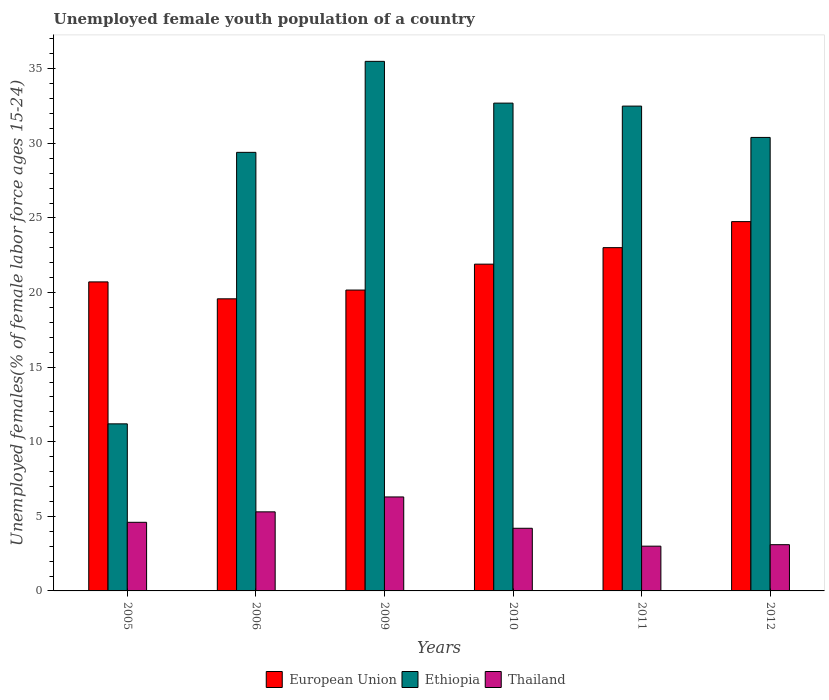How many different coloured bars are there?
Your response must be concise. 3. Are the number of bars per tick equal to the number of legend labels?
Your response must be concise. Yes. How many bars are there on the 6th tick from the left?
Provide a short and direct response. 3. How many bars are there on the 6th tick from the right?
Provide a short and direct response. 3. What is the label of the 2nd group of bars from the left?
Keep it short and to the point. 2006. In how many cases, is the number of bars for a given year not equal to the number of legend labels?
Your answer should be very brief. 0. What is the percentage of unemployed female youth population in European Union in 2009?
Offer a terse response. 20.17. Across all years, what is the maximum percentage of unemployed female youth population in Thailand?
Offer a very short reply. 6.3. Across all years, what is the minimum percentage of unemployed female youth population in Thailand?
Offer a very short reply. 3. What is the total percentage of unemployed female youth population in Ethiopia in the graph?
Your answer should be compact. 171.7. What is the difference between the percentage of unemployed female youth population in European Union in 2011 and that in 2012?
Keep it short and to the point. -1.75. What is the difference between the percentage of unemployed female youth population in Ethiopia in 2010 and the percentage of unemployed female youth population in European Union in 2012?
Give a very brief answer. 7.94. What is the average percentage of unemployed female youth population in Ethiopia per year?
Make the answer very short. 28.62. In the year 2006, what is the difference between the percentage of unemployed female youth population in European Union and percentage of unemployed female youth population in Thailand?
Your answer should be compact. 14.28. What is the ratio of the percentage of unemployed female youth population in Thailand in 2009 to that in 2011?
Your answer should be compact. 2.1. Is the difference between the percentage of unemployed female youth population in European Union in 2005 and 2009 greater than the difference between the percentage of unemployed female youth population in Thailand in 2005 and 2009?
Offer a terse response. Yes. What is the difference between the highest and the second highest percentage of unemployed female youth population in Thailand?
Provide a short and direct response. 1. What is the difference between the highest and the lowest percentage of unemployed female youth population in Thailand?
Give a very brief answer. 3.3. In how many years, is the percentage of unemployed female youth population in Thailand greater than the average percentage of unemployed female youth population in Thailand taken over all years?
Offer a terse response. 3. What does the 2nd bar from the left in 2010 represents?
Provide a short and direct response. Ethiopia. What does the 2nd bar from the right in 2006 represents?
Keep it short and to the point. Ethiopia. Is it the case that in every year, the sum of the percentage of unemployed female youth population in Thailand and percentage of unemployed female youth population in Ethiopia is greater than the percentage of unemployed female youth population in European Union?
Keep it short and to the point. No. How many years are there in the graph?
Your response must be concise. 6. What is the difference between two consecutive major ticks on the Y-axis?
Make the answer very short. 5. Does the graph contain any zero values?
Provide a short and direct response. No. Does the graph contain grids?
Provide a succinct answer. No. How many legend labels are there?
Make the answer very short. 3. How are the legend labels stacked?
Keep it short and to the point. Horizontal. What is the title of the graph?
Provide a succinct answer. Unemployed female youth population of a country. Does "Guatemala" appear as one of the legend labels in the graph?
Offer a very short reply. No. What is the label or title of the X-axis?
Offer a very short reply. Years. What is the label or title of the Y-axis?
Your answer should be very brief. Unemployed females(% of female labor force ages 15-24). What is the Unemployed females(% of female labor force ages 15-24) of European Union in 2005?
Make the answer very short. 20.72. What is the Unemployed females(% of female labor force ages 15-24) in Ethiopia in 2005?
Give a very brief answer. 11.2. What is the Unemployed females(% of female labor force ages 15-24) of Thailand in 2005?
Your answer should be compact. 4.6. What is the Unemployed females(% of female labor force ages 15-24) of European Union in 2006?
Your answer should be very brief. 19.58. What is the Unemployed females(% of female labor force ages 15-24) of Ethiopia in 2006?
Give a very brief answer. 29.4. What is the Unemployed females(% of female labor force ages 15-24) of Thailand in 2006?
Ensure brevity in your answer.  5.3. What is the Unemployed females(% of female labor force ages 15-24) of European Union in 2009?
Your response must be concise. 20.17. What is the Unemployed females(% of female labor force ages 15-24) of Ethiopia in 2009?
Your answer should be compact. 35.5. What is the Unemployed females(% of female labor force ages 15-24) of Thailand in 2009?
Give a very brief answer. 6.3. What is the Unemployed females(% of female labor force ages 15-24) in European Union in 2010?
Ensure brevity in your answer.  21.91. What is the Unemployed females(% of female labor force ages 15-24) of Ethiopia in 2010?
Offer a terse response. 32.7. What is the Unemployed females(% of female labor force ages 15-24) of Thailand in 2010?
Your answer should be compact. 4.2. What is the Unemployed females(% of female labor force ages 15-24) in European Union in 2011?
Your answer should be compact. 23.01. What is the Unemployed females(% of female labor force ages 15-24) of Ethiopia in 2011?
Your answer should be very brief. 32.5. What is the Unemployed females(% of female labor force ages 15-24) of European Union in 2012?
Make the answer very short. 24.76. What is the Unemployed females(% of female labor force ages 15-24) in Ethiopia in 2012?
Offer a very short reply. 30.4. What is the Unemployed females(% of female labor force ages 15-24) in Thailand in 2012?
Offer a very short reply. 3.1. Across all years, what is the maximum Unemployed females(% of female labor force ages 15-24) in European Union?
Make the answer very short. 24.76. Across all years, what is the maximum Unemployed females(% of female labor force ages 15-24) of Ethiopia?
Provide a succinct answer. 35.5. Across all years, what is the maximum Unemployed females(% of female labor force ages 15-24) in Thailand?
Give a very brief answer. 6.3. Across all years, what is the minimum Unemployed females(% of female labor force ages 15-24) of European Union?
Ensure brevity in your answer.  19.58. Across all years, what is the minimum Unemployed females(% of female labor force ages 15-24) in Ethiopia?
Offer a very short reply. 11.2. What is the total Unemployed females(% of female labor force ages 15-24) of European Union in the graph?
Keep it short and to the point. 130.14. What is the total Unemployed females(% of female labor force ages 15-24) of Ethiopia in the graph?
Give a very brief answer. 171.7. What is the difference between the Unemployed females(% of female labor force ages 15-24) in European Union in 2005 and that in 2006?
Offer a terse response. 1.13. What is the difference between the Unemployed females(% of female labor force ages 15-24) in Ethiopia in 2005 and that in 2006?
Offer a very short reply. -18.2. What is the difference between the Unemployed females(% of female labor force ages 15-24) of European Union in 2005 and that in 2009?
Offer a very short reply. 0.55. What is the difference between the Unemployed females(% of female labor force ages 15-24) of Ethiopia in 2005 and that in 2009?
Keep it short and to the point. -24.3. What is the difference between the Unemployed females(% of female labor force ages 15-24) of Thailand in 2005 and that in 2009?
Give a very brief answer. -1.7. What is the difference between the Unemployed females(% of female labor force ages 15-24) in European Union in 2005 and that in 2010?
Provide a succinct answer. -1.19. What is the difference between the Unemployed females(% of female labor force ages 15-24) of Ethiopia in 2005 and that in 2010?
Your answer should be very brief. -21.5. What is the difference between the Unemployed females(% of female labor force ages 15-24) of Thailand in 2005 and that in 2010?
Your answer should be compact. 0.4. What is the difference between the Unemployed females(% of female labor force ages 15-24) of European Union in 2005 and that in 2011?
Your answer should be compact. -2.3. What is the difference between the Unemployed females(% of female labor force ages 15-24) in Ethiopia in 2005 and that in 2011?
Your answer should be compact. -21.3. What is the difference between the Unemployed females(% of female labor force ages 15-24) in European Union in 2005 and that in 2012?
Offer a terse response. -4.04. What is the difference between the Unemployed females(% of female labor force ages 15-24) in Ethiopia in 2005 and that in 2012?
Give a very brief answer. -19.2. What is the difference between the Unemployed females(% of female labor force ages 15-24) in Thailand in 2005 and that in 2012?
Your answer should be compact. 1.5. What is the difference between the Unemployed females(% of female labor force ages 15-24) of European Union in 2006 and that in 2009?
Your response must be concise. -0.59. What is the difference between the Unemployed females(% of female labor force ages 15-24) in Thailand in 2006 and that in 2009?
Your answer should be very brief. -1. What is the difference between the Unemployed females(% of female labor force ages 15-24) of European Union in 2006 and that in 2010?
Your response must be concise. -2.32. What is the difference between the Unemployed females(% of female labor force ages 15-24) of Thailand in 2006 and that in 2010?
Your answer should be compact. 1.1. What is the difference between the Unemployed females(% of female labor force ages 15-24) of European Union in 2006 and that in 2011?
Ensure brevity in your answer.  -3.43. What is the difference between the Unemployed females(% of female labor force ages 15-24) of European Union in 2006 and that in 2012?
Ensure brevity in your answer.  -5.18. What is the difference between the Unemployed females(% of female labor force ages 15-24) in European Union in 2009 and that in 2010?
Ensure brevity in your answer.  -1.74. What is the difference between the Unemployed females(% of female labor force ages 15-24) of Ethiopia in 2009 and that in 2010?
Give a very brief answer. 2.8. What is the difference between the Unemployed females(% of female labor force ages 15-24) in European Union in 2009 and that in 2011?
Make the answer very short. -2.84. What is the difference between the Unemployed females(% of female labor force ages 15-24) in Ethiopia in 2009 and that in 2011?
Give a very brief answer. 3. What is the difference between the Unemployed females(% of female labor force ages 15-24) in Thailand in 2009 and that in 2011?
Your response must be concise. 3.3. What is the difference between the Unemployed females(% of female labor force ages 15-24) in European Union in 2009 and that in 2012?
Give a very brief answer. -4.59. What is the difference between the Unemployed females(% of female labor force ages 15-24) in Ethiopia in 2009 and that in 2012?
Provide a short and direct response. 5.1. What is the difference between the Unemployed females(% of female labor force ages 15-24) of Thailand in 2009 and that in 2012?
Make the answer very short. 3.2. What is the difference between the Unemployed females(% of female labor force ages 15-24) of European Union in 2010 and that in 2011?
Ensure brevity in your answer.  -1.11. What is the difference between the Unemployed females(% of female labor force ages 15-24) in Thailand in 2010 and that in 2011?
Your answer should be very brief. 1.2. What is the difference between the Unemployed females(% of female labor force ages 15-24) of European Union in 2010 and that in 2012?
Make the answer very short. -2.85. What is the difference between the Unemployed females(% of female labor force ages 15-24) in European Union in 2011 and that in 2012?
Your response must be concise. -1.75. What is the difference between the Unemployed females(% of female labor force ages 15-24) in European Union in 2005 and the Unemployed females(% of female labor force ages 15-24) in Ethiopia in 2006?
Provide a short and direct response. -8.68. What is the difference between the Unemployed females(% of female labor force ages 15-24) in European Union in 2005 and the Unemployed females(% of female labor force ages 15-24) in Thailand in 2006?
Ensure brevity in your answer.  15.42. What is the difference between the Unemployed females(% of female labor force ages 15-24) of European Union in 2005 and the Unemployed females(% of female labor force ages 15-24) of Ethiopia in 2009?
Your answer should be very brief. -14.78. What is the difference between the Unemployed females(% of female labor force ages 15-24) in European Union in 2005 and the Unemployed females(% of female labor force ages 15-24) in Thailand in 2009?
Provide a succinct answer. 14.42. What is the difference between the Unemployed females(% of female labor force ages 15-24) of European Union in 2005 and the Unemployed females(% of female labor force ages 15-24) of Ethiopia in 2010?
Make the answer very short. -11.98. What is the difference between the Unemployed females(% of female labor force ages 15-24) of European Union in 2005 and the Unemployed females(% of female labor force ages 15-24) of Thailand in 2010?
Your answer should be very brief. 16.52. What is the difference between the Unemployed females(% of female labor force ages 15-24) in Ethiopia in 2005 and the Unemployed females(% of female labor force ages 15-24) in Thailand in 2010?
Offer a terse response. 7. What is the difference between the Unemployed females(% of female labor force ages 15-24) in European Union in 2005 and the Unemployed females(% of female labor force ages 15-24) in Ethiopia in 2011?
Make the answer very short. -11.78. What is the difference between the Unemployed females(% of female labor force ages 15-24) in European Union in 2005 and the Unemployed females(% of female labor force ages 15-24) in Thailand in 2011?
Offer a terse response. 17.72. What is the difference between the Unemployed females(% of female labor force ages 15-24) in Ethiopia in 2005 and the Unemployed females(% of female labor force ages 15-24) in Thailand in 2011?
Ensure brevity in your answer.  8.2. What is the difference between the Unemployed females(% of female labor force ages 15-24) of European Union in 2005 and the Unemployed females(% of female labor force ages 15-24) of Ethiopia in 2012?
Your response must be concise. -9.68. What is the difference between the Unemployed females(% of female labor force ages 15-24) in European Union in 2005 and the Unemployed females(% of female labor force ages 15-24) in Thailand in 2012?
Provide a succinct answer. 17.62. What is the difference between the Unemployed females(% of female labor force ages 15-24) of European Union in 2006 and the Unemployed females(% of female labor force ages 15-24) of Ethiopia in 2009?
Your answer should be very brief. -15.92. What is the difference between the Unemployed females(% of female labor force ages 15-24) in European Union in 2006 and the Unemployed females(% of female labor force ages 15-24) in Thailand in 2009?
Provide a succinct answer. 13.28. What is the difference between the Unemployed females(% of female labor force ages 15-24) in Ethiopia in 2006 and the Unemployed females(% of female labor force ages 15-24) in Thailand in 2009?
Provide a succinct answer. 23.1. What is the difference between the Unemployed females(% of female labor force ages 15-24) in European Union in 2006 and the Unemployed females(% of female labor force ages 15-24) in Ethiopia in 2010?
Your response must be concise. -13.12. What is the difference between the Unemployed females(% of female labor force ages 15-24) of European Union in 2006 and the Unemployed females(% of female labor force ages 15-24) of Thailand in 2010?
Give a very brief answer. 15.38. What is the difference between the Unemployed females(% of female labor force ages 15-24) of Ethiopia in 2006 and the Unemployed females(% of female labor force ages 15-24) of Thailand in 2010?
Your answer should be compact. 25.2. What is the difference between the Unemployed females(% of female labor force ages 15-24) of European Union in 2006 and the Unemployed females(% of female labor force ages 15-24) of Ethiopia in 2011?
Keep it short and to the point. -12.92. What is the difference between the Unemployed females(% of female labor force ages 15-24) of European Union in 2006 and the Unemployed females(% of female labor force ages 15-24) of Thailand in 2011?
Make the answer very short. 16.58. What is the difference between the Unemployed females(% of female labor force ages 15-24) of Ethiopia in 2006 and the Unemployed females(% of female labor force ages 15-24) of Thailand in 2011?
Provide a succinct answer. 26.4. What is the difference between the Unemployed females(% of female labor force ages 15-24) in European Union in 2006 and the Unemployed females(% of female labor force ages 15-24) in Ethiopia in 2012?
Ensure brevity in your answer.  -10.82. What is the difference between the Unemployed females(% of female labor force ages 15-24) of European Union in 2006 and the Unemployed females(% of female labor force ages 15-24) of Thailand in 2012?
Provide a succinct answer. 16.48. What is the difference between the Unemployed females(% of female labor force ages 15-24) of Ethiopia in 2006 and the Unemployed females(% of female labor force ages 15-24) of Thailand in 2012?
Make the answer very short. 26.3. What is the difference between the Unemployed females(% of female labor force ages 15-24) of European Union in 2009 and the Unemployed females(% of female labor force ages 15-24) of Ethiopia in 2010?
Offer a terse response. -12.53. What is the difference between the Unemployed females(% of female labor force ages 15-24) of European Union in 2009 and the Unemployed females(% of female labor force ages 15-24) of Thailand in 2010?
Give a very brief answer. 15.97. What is the difference between the Unemployed females(% of female labor force ages 15-24) in Ethiopia in 2009 and the Unemployed females(% of female labor force ages 15-24) in Thailand in 2010?
Provide a succinct answer. 31.3. What is the difference between the Unemployed females(% of female labor force ages 15-24) of European Union in 2009 and the Unemployed females(% of female labor force ages 15-24) of Ethiopia in 2011?
Make the answer very short. -12.33. What is the difference between the Unemployed females(% of female labor force ages 15-24) of European Union in 2009 and the Unemployed females(% of female labor force ages 15-24) of Thailand in 2011?
Ensure brevity in your answer.  17.17. What is the difference between the Unemployed females(% of female labor force ages 15-24) of Ethiopia in 2009 and the Unemployed females(% of female labor force ages 15-24) of Thailand in 2011?
Provide a short and direct response. 32.5. What is the difference between the Unemployed females(% of female labor force ages 15-24) in European Union in 2009 and the Unemployed females(% of female labor force ages 15-24) in Ethiopia in 2012?
Offer a terse response. -10.23. What is the difference between the Unemployed females(% of female labor force ages 15-24) in European Union in 2009 and the Unemployed females(% of female labor force ages 15-24) in Thailand in 2012?
Your answer should be compact. 17.07. What is the difference between the Unemployed females(% of female labor force ages 15-24) in Ethiopia in 2009 and the Unemployed females(% of female labor force ages 15-24) in Thailand in 2012?
Keep it short and to the point. 32.4. What is the difference between the Unemployed females(% of female labor force ages 15-24) in European Union in 2010 and the Unemployed females(% of female labor force ages 15-24) in Ethiopia in 2011?
Your answer should be very brief. -10.6. What is the difference between the Unemployed females(% of female labor force ages 15-24) in European Union in 2010 and the Unemployed females(% of female labor force ages 15-24) in Thailand in 2011?
Ensure brevity in your answer.  18.91. What is the difference between the Unemployed females(% of female labor force ages 15-24) in Ethiopia in 2010 and the Unemployed females(% of female labor force ages 15-24) in Thailand in 2011?
Keep it short and to the point. 29.7. What is the difference between the Unemployed females(% of female labor force ages 15-24) of European Union in 2010 and the Unemployed females(% of female labor force ages 15-24) of Ethiopia in 2012?
Make the answer very short. -8.49. What is the difference between the Unemployed females(% of female labor force ages 15-24) in European Union in 2010 and the Unemployed females(% of female labor force ages 15-24) in Thailand in 2012?
Ensure brevity in your answer.  18.8. What is the difference between the Unemployed females(% of female labor force ages 15-24) of Ethiopia in 2010 and the Unemployed females(% of female labor force ages 15-24) of Thailand in 2012?
Offer a very short reply. 29.6. What is the difference between the Unemployed females(% of female labor force ages 15-24) in European Union in 2011 and the Unemployed females(% of female labor force ages 15-24) in Ethiopia in 2012?
Provide a succinct answer. -7.39. What is the difference between the Unemployed females(% of female labor force ages 15-24) in European Union in 2011 and the Unemployed females(% of female labor force ages 15-24) in Thailand in 2012?
Offer a terse response. 19.91. What is the difference between the Unemployed females(% of female labor force ages 15-24) in Ethiopia in 2011 and the Unemployed females(% of female labor force ages 15-24) in Thailand in 2012?
Your answer should be very brief. 29.4. What is the average Unemployed females(% of female labor force ages 15-24) of European Union per year?
Ensure brevity in your answer.  21.69. What is the average Unemployed females(% of female labor force ages 15-24) of Ethiopia per year?
Ensure brevity in your answer.  28.62. What is the average Unemployed females(% of female labor force ages 15-24) of Thailand per year?
Your answer should be very brief. 4.42. In the year 2005, what is the difference between the Unemployed females(% of female labor force ages 15-24) in European Union and Unemployed females(% of female labor force ages 15-24) in Ethiopia?
Offer a terse response. 9.52. In the year 2005, what is the difference between the Unemployed females(% of female labor force ages 15-24) in European Union and Unemployed females(% of female labor force ages 15-24) in Thailand?
Offer a terse response. 16.12. In the year 2005, what is the difference between the Unemployed females(% of female labor force ages 15-24) in Ethiopia and Unemployed females(% of female labor force ages 15-24) in Thailand?
Your answer should be compact. 6.6. In the year 2006, what is the difference between the Unemployed females(% of female labor force ages 15-24) of European Union and Unemployed females(% of female labor force ages 15-24) of Ethiopia?
Give a very brief answer. -9.82. In the year 2006, what is the difference between the Unemployed females(% of female labor force ages 15-24) of European Union and Unemployed females(% of female labor force ages 15-24) of Thailand?
Offer a terse response. 14.28. In the year 2006, what is the difference between the Unemployed females(% of female labor force ages 15-24) in Ethiopia and Unemployed females(% of female labor force ages 15-24) in Thailand?
Your answer should be compact. 24.1. In the year 2009, what is the difference between the Unemployed females(% of female labor force ages 15-24) in European Union and Unemployed females(% of female labor force ages 15-24) in Ethiopia?
Make the answer very short. -15.33. In the year 2009, what is the difference between the Unemployed females(% of female labor force ages 15-24) of European Union and Unemployed females(% of female labor force ages 15-24) of Thailand?
Offer a terse response. 13.87. In the year 2009, what is the difference between the Unemployed females(% of female labor force ages 15-24) in Ethiopia and Unemployed females(% of female labor force ages 15-24) in Thailand?
Make the answer very short. 29.2. In the year 2010, what is the difference between the Unemployed females(% of female labor force ages 15-24) of European Union and Unemployed females(% of female labor force ages 15-24) of Ethiopia?
Offer a very short reply. -10.79. In the year 2010, what is the difference between the Unemployed females(% of female labor force ages 15-24) in European Union and Unemployed females(% of female labor force ages 15-24) in Thailand?
Your answer should be very brief. 17.7. In the year 2010, what is the difference between the Unemployed females(% of female labor force ages 15-24) in Ethiopia and Unemployed females(% of female labor force ages 15-24) in Thailand?
Your answer should be compact. 28.5. In the year 2011, what is the difference between the Unemployed females(% of female labor force ages 15-24) of European Union and Unemployed females(% of female labor force ages 15-24) of Ethiopia?
Provide a short and direct response. -9.49. In the year 2011, what is the difference between the Unemployed females(% of female labor force ages 15-24) of European Union and Unemployed females(% of female labor force ages 15-24) of Thailand?
Your answer should be very brief. 20.01. In the year 2011, what is the difference between the Unemployed females(% of female labor force ages 15-24) in Ethiopia and Unemployed females(% of female labor force ages 15-24) in Thailand?
Provide a succinct answer. 29.5. In the year 2012, what is the difference between the Unemployed females(% of female labor force ages 15-24) in European Union and Unemployed females(% of female labor force ages 15-24) in Ethiopia?
Ensure brevity in your answer.  -5.64. In the year 2012, what is the difference between the Unemployed females(% of female labor force ages 15-24) in European Union and Unemployed females(% of female labor force ages 15-24) in Thailand?
Your answer should be very brief. 21.66. In the year 2012, what is the difference between the Unemployed females(% of female labor force ages 15-24) of Ethiopia and Unemployed females(% of female labor force ages 15-24) of Thailand?
Your response must be concise. 27.3. What is the ratio of the Unemployed females(% of female labor force ages 15-24) of European Union in 2005 to that in 2006?
Your response must be concise. 1.06. What is the ratio of the Unemployed females(% of female labor force ages 15-24) in Ethiopia in 2005 to that in 2006?
Make the answer very short. 0.38. What is the ratio of the Unemployed females(% of female labor force ages 15-24) of Thailand in 2005 to that in 2006?
Make the answer very short. 0.87. What is the ratio of the Unemployed females(% of female labor force ages 15-24) of European Union in 2005 to that in 2009?
Offer a very short reply. 1.03. What is the ratio of the Unemployed females(% of female labor force ages 15-24) of Ethiopia in 2005 to that in 2009?
Provide a short and direct response. 0.32. What is the ratio of the Unemployed females(% of female labor force ages 15-24) in Thailand in 2005 to that in 2009?
Offer a very short reply. 0.73. What is the ratio of the Unemployed females(% of female labor force ages 15-24) in European Union in 2005 to that in 2010?
Offer a very short reply. 0.95. What is the ratio of the Unemployed females(% of female labor force ages 15-24) in Ethiopia in 2005 to that in 2010?
Your answer should be very brief. 0.34. What is the ratio of the Unemployed females(% of female labor force ages 15-24) in Thailand in 2005 to that in 2010?
Provide a short and direct response. 1.1. What is the ratio of the Unemployed females(% of female labor force ages 15-24) in European Union in 2005 to that in 2011?
Your answer should be compact. 0.9. What is the ratio of the Unemployed females(% of female labor force ages 15-24) of Ethiopia in 2005 to that in 2011?
Keep it short and to the point. 0.34. What is the ratio of the Unemployed females(% of female labor force ages 15-24) of Thailand in 2005 to that in 2011?
Make the answer very short. 1.53. What is the ratio of the Unemployed females(% of female labor force ages 15-24) of European Union in 2005 to that in 2012?
Ensure brevity in your answer.  0.84. What is the ratio of the Unemployed females(% of female labor force ages 15-24) of Ethiopia in 2005 to that in 2012?
Ensure brevity in your answer.  0.37. What is the ratio of the Unemployed females(% of female labor force ages 15-24) of Thailand in 2005 to that in 2012?
Offer a very short reply. 1.48. What is the ratio of the Unemployed females(% of female labor force ages 15-24) of European Union in 2006 to that in 2009?
Your answer should be very brief. 0.97. What is the ratio of the Unemployed females(% of female labor force ages 15-24) of Ethiopia in 2006 to that in 2009?
Offer a very short reply. 0.83. What is the ratio of the Unemployed females(% of female labor force ages 15-24) in Thailand in 2006 to that in 2009?
Keep it short and to the point. 0.84. What is the ratio of the Unemployed females(% of female labor force ages 15-24) of European Union in 2006 to that in 2010?
Provide a short and direct response. 0.89. What is the ratio of the Unemployed females(% of female labor force ages 15-24) of Ethiopia in 2006 to that in 2010?
Provide a succinct answer. 0.9. What is the ratio of the Unemployed females(% of female labor force ages 15-24) in Thailand in 2006 to that in 2010?
Your answer should be very brief. 1.26. What is the ratio of the Unemployed females(% of female labor force ages 15-24) in European Union in 2006 to that in 2011?
Your response must be concise. 0.85. What is the ratio of the Unemployed females(% of female labor force ages 15-24) of Ethiopia in 2006 to that in 2011?
Offer a very short reply. 0.9. What is the ratio of the Unemployed females(% of female labor force ages 15-24) in Thailand in 2006 to that in 2011?
Your response must be concise. 1.77. What is the ratio of the Unemployed females(% of female labor force ages 15-24) of European Union in 2006 to that in 2012?
Provide a succinct answer. 0.79. What is the ratio of the Unemployed females(% of female labor force ages 15-24) of Ethiopia in 2006 to that in 2012?
Your response must be concise. 0.97. What is the ratio of the Unemployed females(% of female labor force ages 15-24) of Thailand in 2006 to that in 2012?
Provide a short and direct response. 1.71. What is the ratio of the Unemployed females(% of female labor force ages 15-24) of European Union in 2009 to that in 2010?
Keep it short and to the point. 0.92. What is the ratio of the Unemployed females(% of female labor force ages 15-24) in Ethiopia in 2009 to that in 2010?
Give a very brief answer. 1.09. What is the ratio of the Unemployed females(% of female labor force ages 15-24) in Thailand in 2009 to that in 2010?
Offer a terse response. 1.5. What is the ratio of the Unemployed females(% of female labor force ages 15-24) of European Union in 2009 to that in 2011?
Provide a short and direct response. 0.88. What is the ratio of the Unemployed females(% of female labor force ages 15-24) in Ethiopia in 2009 to that in 2011?
Keep it short and to the point. 1.09. What is the ratio of the Unemployed females(% of female labor force ages 15-24) of Thailand in 2009 to that in 2011?
Your answer should be very brief. 2.1. What is the ratio of the Unemployed females(% of female labor force ages 15-24) in European Union in 2009 to that in 2012?
Give a very brief answer. 0.81. What is the ratio of the Unemployed females(% of female labor force ages 15-24) in Ethiopia in 2009 to that in 2012?
Make the answer very short. 1.17. What is the ratio of the Unemployed females(% of female labor force ages 15-24) of Thailand in 2009 to that in 2012?
Ensure brevity in your answer.  2.03. What is the ratio of the Unemployed females(% of female labor force ages 15-24) of European Union in 2010 to that in 2011?
Provide a succinct answer. 0.95. What is the ratio of the Unemployed females(% of female labor force ages 15-24) in Thailand in 2010 to that in 2011?
Your response must be concise. 1.4. What is the ratio of the Unemployed females(% of female labor force ages 15-24) of European Union in 2010 to that in 2012?
Ensure brevity in your answer.  0.88. What is the ratio of the Unemployed females(% of female labor force ages 15-24) in Ethiopia in 2010 to that in 2012?
Provide a short and direct response. 1.08. What is the ratio of the Unemployed females(% of female labor force ages 15-24) of Thailand in 2010 to that in 2012?
Provide a succinct answer. 1.35. What is the ratio of the Unemployed females(% of female labor force ages 15-24) of European Union in 2011 to that in 2012?
Your response must be concise. 0.93. What is the ratio of the Unemployed females(% of female labor force ages 15-24) in Ethiopia in 2011 to that in 2012?
Provide a short and direct response. 1.07. What is the ratio of the Unemployed females(% of female labor force ages 15-24) of Thailand in 2011 to that in 2012?
Offer a very short reply. 0.97. What is the difference between the highest and the second highest Unemployed females(% of female labor force ages 15-24) of European Union?
Your answer should be compact. 1.75. What is the difference between the highest and the lowest Unemployed females(% of female labor force ages 15-24) in European Union?
Your answer should be compact. 5.18. What is the difference between the highest and the lowest Unemployed females(% of female labor force ages 15-24) of Ethiopia?
Offer a very short reply. 24.3. 